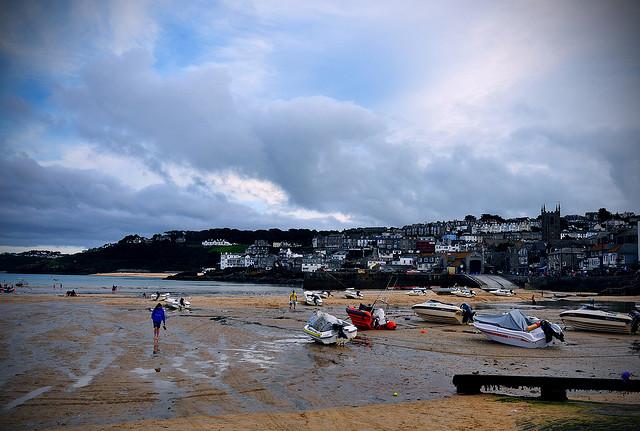What is sticking out of the mud?
Short answer required. Boats. Do any of these boats go in the water?
Quick response, please. Yes. Is that snow?
Be succinct. No. What are these boats doing?
Keep it brief. Sitting. Why are the boats parked on the beach?
Quick response, please. Low tide. 